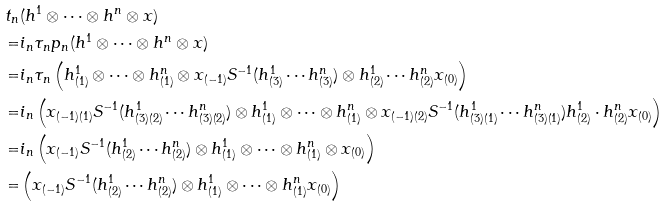<formula> <loc_0><loc_0><loc_500><loc_500>t _ { n } & ( h ^ { 1 } \otimes \cdots \otimes h ^ { n } \otimes x ) \\ = & i _ { n } \tau _ { n } p _ { n } ( h ^ { 1 } \otimes \cdots \otimes h ^ { n } \otimes x ) \\ = & i _ { n } \tau _ { n } \left ( h ^ { 1 } _ { ( 1 ) } \otimes \cdots \otimes h ^ { n } _ { ( 1 ) } \otimes x _ { ( - 1 ) } S ^ { - 1 } ( h ^ { 1 } _ { ( 3 ) } \cdots h ^ { n } _ { ( 3 ) } ) \otimes h ^ { 1 } _ { ( 2 ) } \cdots h ^ { n } _ { ( 2 ) } x _ { ( 0 ) } \right ) \\ = & i _ { n } \left ( x _ { ( - 1 ) ( 1 ) } S ^ { - 1 } ( h ^ { 1 } _ { ( 3 ) ( 2 ) } \cdots h ^ { n } _ { ( 3 ) ( 2 ) } ) \otimes h ^ { 1 } _ { ( 1 ) } \otimes \cdots \otimes h ^ { n } _ { ( 1 ) } \otimes x _ { ( - 1 ) ( 2 ) } S ^ { - 1 } ( h ^ { 1 } _ { ( 3 ) ( 1 ) } \cdots h ^ { n } _ { ( 3 ) ( 1 ) } ) h ^ { 1 } _ { ( 2 ) } \cdot h ^ { n } _ { ( 2 ) } x _ { ( 0 ) } \right ) \\ = & i _ { n } \left ( x _ { ( - 1 ) } S ^ { - 1 } ( h ^ { 1 } _ { ( 2 ) } \cdots h ^ { n } _ { ( 2 ) } ) \otimes h ^ { 1 } _ { ( 1 ) } \otimes \cdots \otimes h ^ { n } _ { ( 1 ) } \otimes x _ { ( 0 ) } \right ) \\ = & \left ( x _ { ( - 1 ) } S ^ { - 1 } ( h ^ { 1 } _ { ( 2 ) } \cdots h ^ { n } _ { ( 2 ) } ) \otimes h ^ { 1 } _ { ( 1 ) } \otimes \cdots \otimes h ^ { n } _ { ( 1 ) } x _ { ( 0 ) } \right )</formula> 